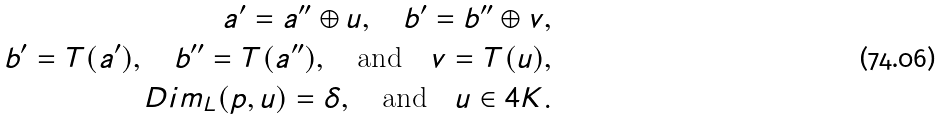Convert formula to latex. <formula><loc_0><loc_0><loc_500><loc_500>a ^ { \prime } = a ^ { \prime \prime } \oplus u , \quad b ^ { \prime } = b ^ { \prime \prime } \oplus v , \\ b ^ { \prime } = T ( a ^ { \prime } ) , \quad b ^ { \prime \prime } = T ( a ^ { \prime \prime } ) , \quad \text {and} \quad v = T ( u ) , \\ \ D i m _ { L } ( p , u ) = \delta , \quad \text {and} \quad u \in 4 K .</formula> 